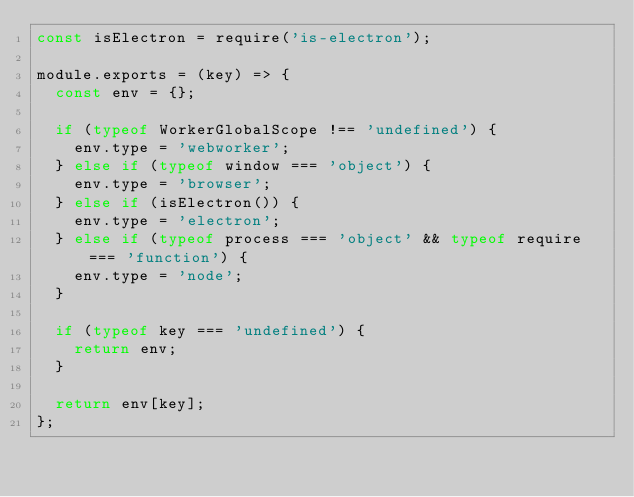Convert code to text. <code><loc_0><loc_0><loc_500><loc_500><_JavaScript_>const isElectron = require('is-electron');

module.exports = (key) => {
  const env = {};

  if (typeof WorkerGlobalScope !== 'undefined') {
    env.type = 'webworker';
  } else if (typeof window === 'object') {
    env.type = 'browser';
  } else if (isElectron()) {
    env.type = 'electron';
  } else if (typeof process === 'object' && typeof require === 'function') {
    env.type = 'node';
  }

  if (typeof key === 'undefined') {
    return env;
  }

  return env[key];
};
</code> 